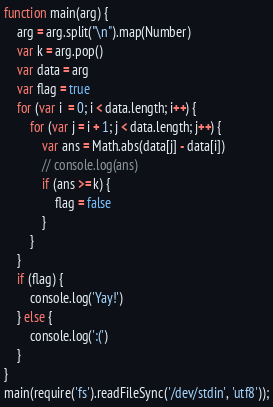Convert code to text. <code><loc_0><loc_0><loc_500><loc_500><_JavaScript_>function main(arg) {
	arg = arg.split("\n").map(Number)
	var k = arg.pop()
	var data = arg
	var flag = true
	for (var i  = 0; i < data.length; i++) {
		for (var j = i + 1; j < data.length; j++) {
			var ans = Math.abs(data[j] - data[i])
			// console.log(ans)
			if (ans >= k) {
				flag = false
			}
		}
	}
	if (flag) {
		console.log('Yay!')
	} else {
		console.log(':(')
	}
}
main(require('fs').readFileSync('/dev/stdin', 'utf8'));</code> 